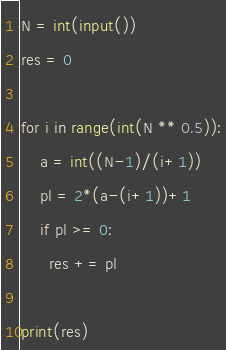<code> <loc_0><loc_0><loc_500><loc_500><_Python_>N = int(input())
res = 0

for i in range(int(N ** 0.5)):
    a = int((N-1)/(i+1))
    pl = 2*(a-(i+1))+1 
    if pl >= 0:
      res += pl

print(res)</code> 